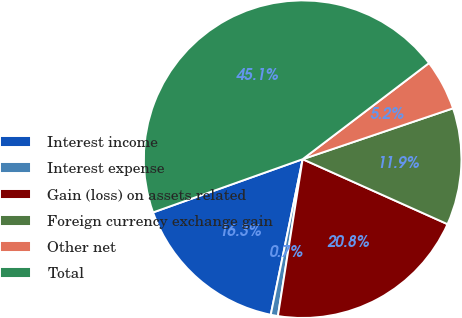Convert chart to OTSL. <chart><loc_0><loc_0><loc_500><loc_500><pie_chart><fcel>Interest income<fcel>Interest expense<fcel>Gain (loss) on assets related<fcel>Foreign currency exchange gain<fcel>Other net<fcel>Total<nl><fcel>16.34%<fcel>0.73%<fcel>20.78%<fcel>11.9%<fcel>5.16%<fcel>45.09%<nl></chart> 